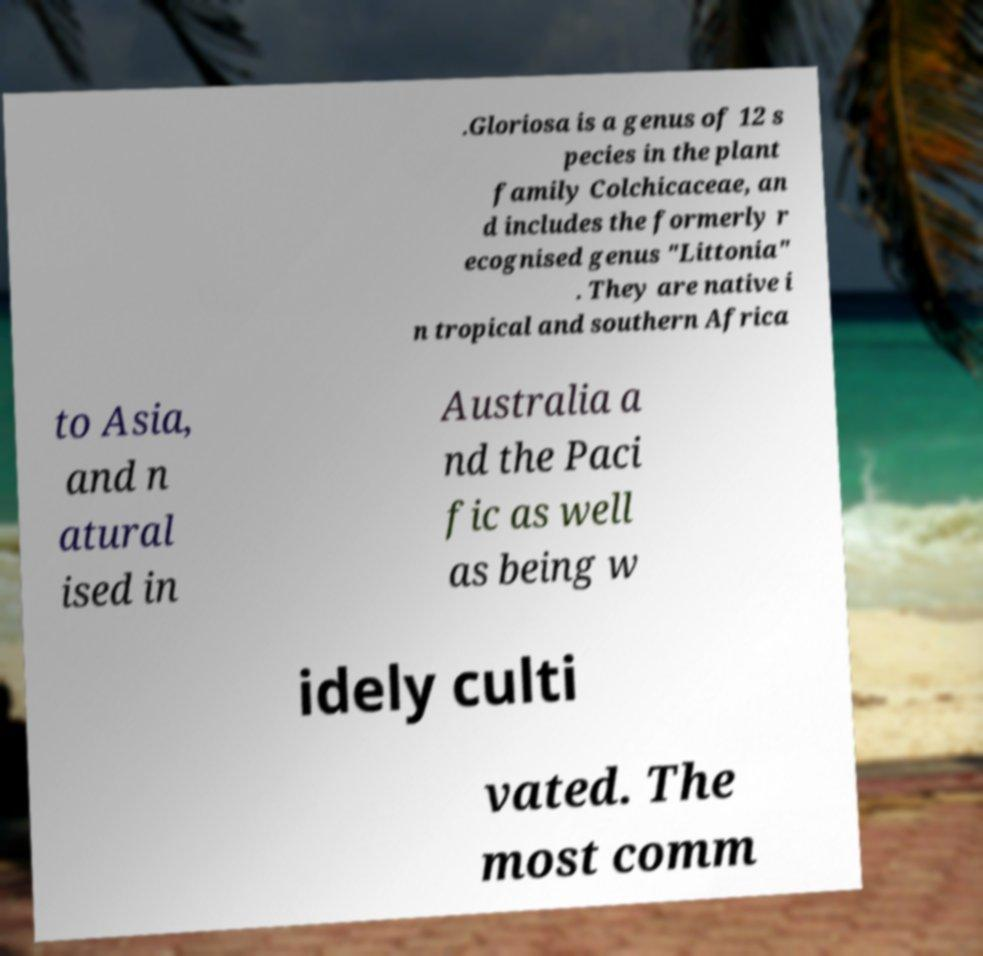Please read and relay the text visible in this image. What does it say? .Gloriosa is a genus of 12 s pecies in the plant family Colchicaceae, an d includes the formerly r ecognised genus "Littonia" . They are native i n tropical and southern Africa to Asia, and n atural ised in Australia a nd the Paci fic as well as being w idely culti vated. The most comm 